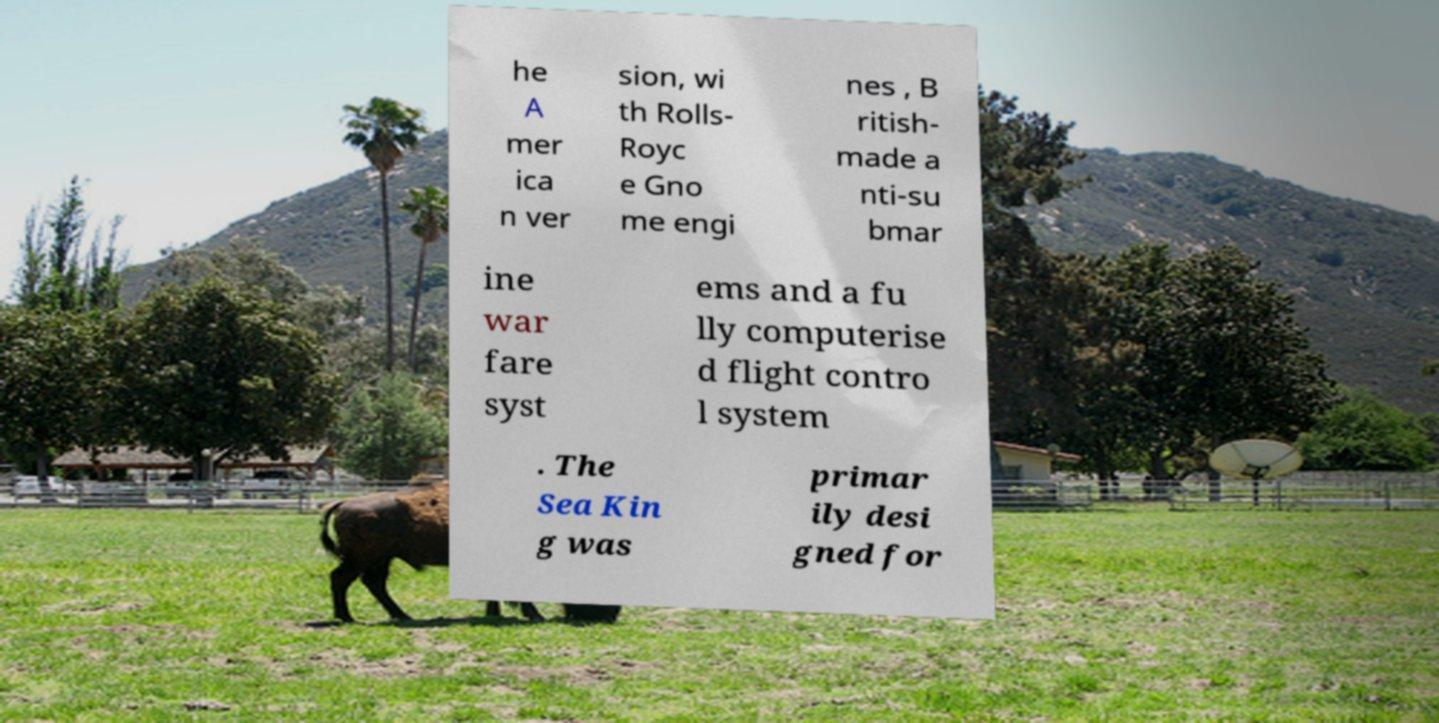There's text embedded in this image that I need extracted. Can you transcribe it verbatim? he A mer ica n ver sion, wi th Rolls- Royc e Gno me engi nes , B ritish- made a nti-su bmar ine war fare syst ems and a fu lly computerise d flight contro l system . The Sea Kin g was primar ily desi gned for 